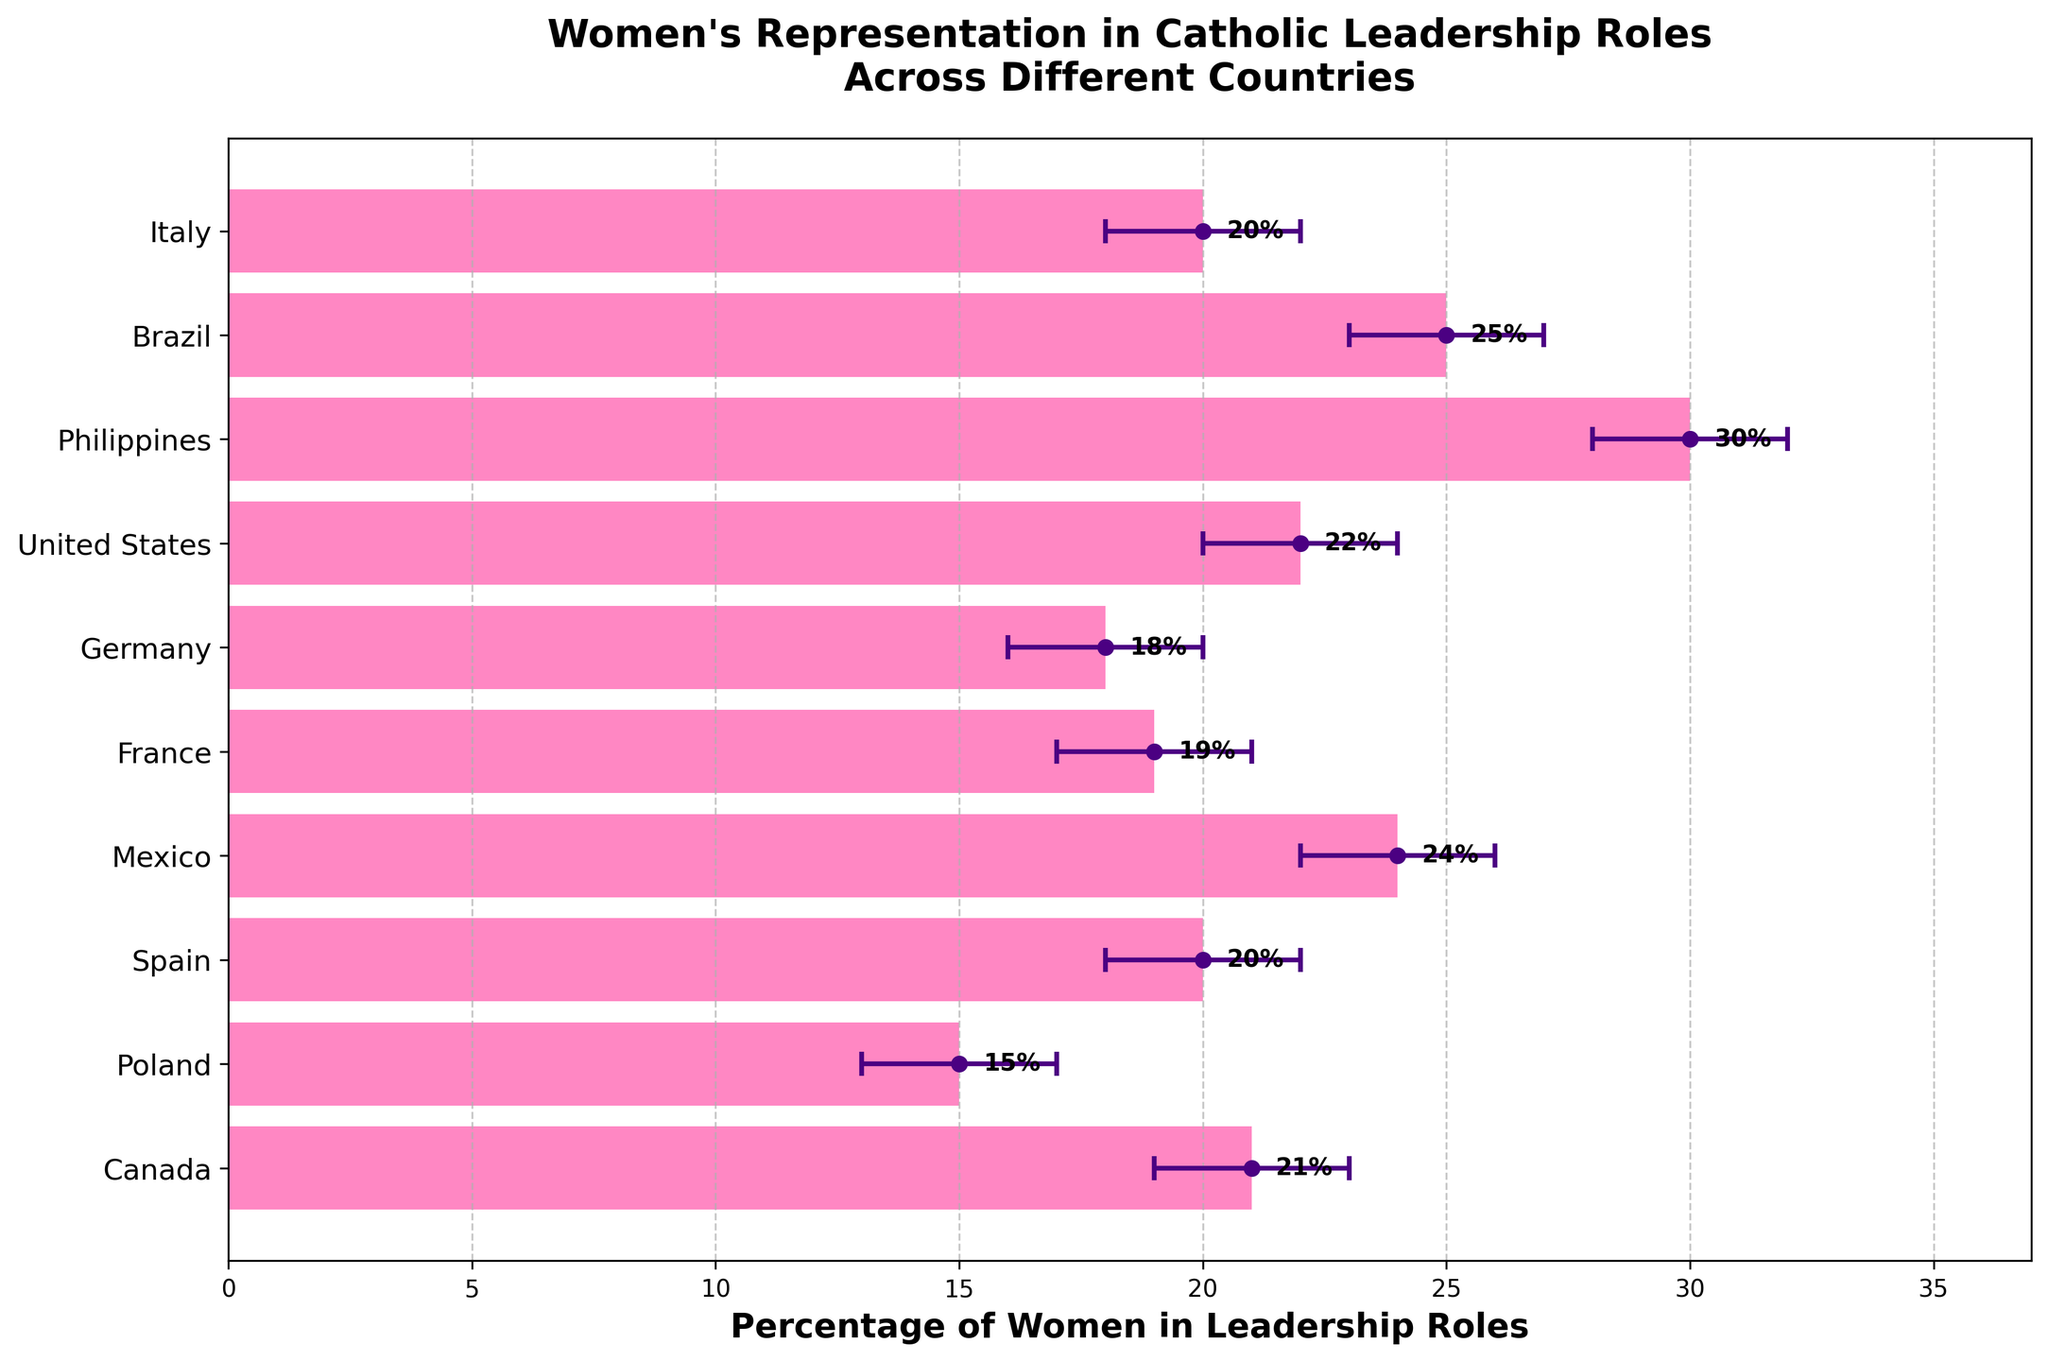what is the title of the figure? The title is prominently displayed at the top of the figure and reads "Women's Representation in Catholic Leadership Roles Across Different Countries".
Answer: Women's Representation in Catholic Leadership Roles Across Different Countries what is the percentage of women in leadership roles in Canada? The figure shows horizontal bars for each country. For Canada, the percentage is labeled at the end of the bar.
Answer: 21% which country has the highest percentage of women in leadership roles? By comparing the lengths of the bars, the Philippines has the longest bar, indicating the highest percentage.
Answer: Philippines how many countries have a lower confidence interval below 20%? From the error bars, count the countries where the lower confidence interval falls below 20%. These countries are Italy, Germany, France, Spain, Poland, and Canada.
Answer: 6 what is the range of the confidence interval for Brazil? The lower interval is 23% and the upper interval is 27%. The range is the difference between these two.
Answer: 4% what trend can you observe about women's representation among these countries? Generally, countries like the Philippines and Brazil have higher women's leadership percentages, while European countries like Germany and Poland tend to have lower percentages.
Answer: Varies by region which country has the smallest error bars, indicating the narrowest confidence interval? By observing the lengths of the error bars, the Philippines and Mexico appear to have the smallest error bars.
Answer: Philippines, Mexico what is the difference in the percentage of women in leadership roles between Mexico and Poland? Subtract the percentage for Poland (15%) from the percentage for Mexico (24%).
Answer: 9% how do Italy and Spain compare in terms of women's leadership percentage and confidence intervals? Both countries have the same leadership percentage (20%), and identical confidence intervals (18% to 22%), indicating similar levels of representation and uncertainty.
Answer: Same percentage and confidence intervals which country shows the largest uncertainty in women's leadership percentage? The width of the error bars shows uncertainty. Germany has the widest error bars (16%-20%), indicating the largest uncertainty.
Answer: Germany 